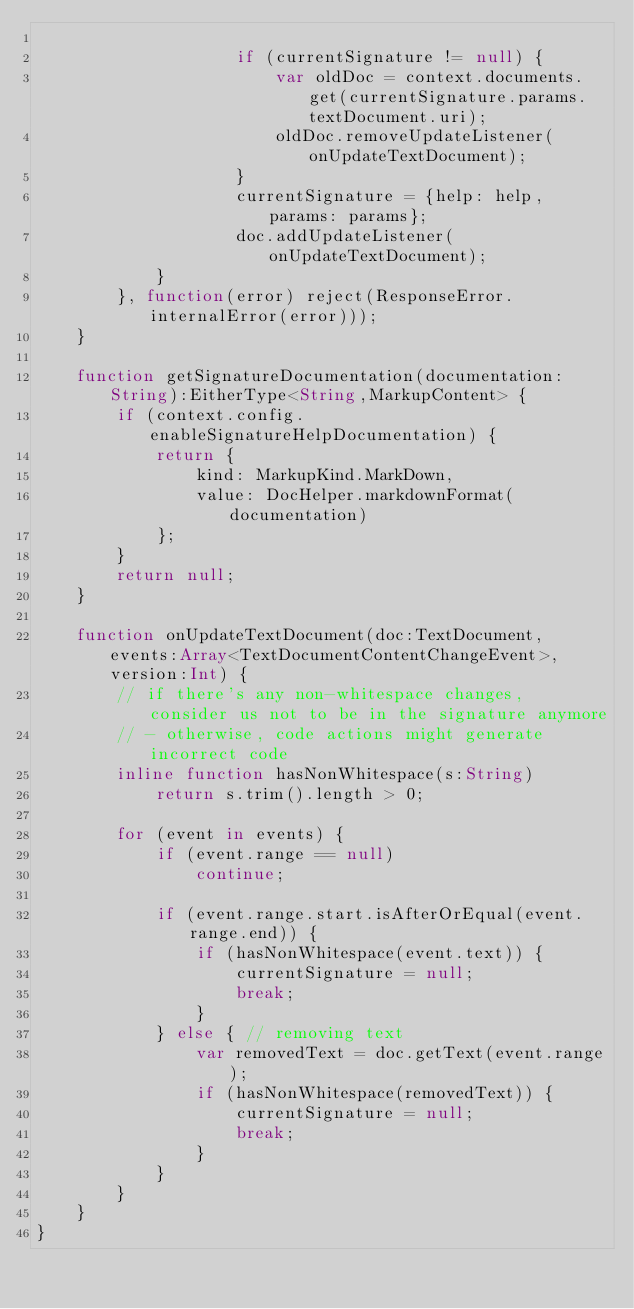Convert code to text. <code><loc_0><loc_0><loc_500><loc_500><_Haxe_>
                    if (currentSignature != null) {
                        var oldDoc = context.documents.get(currentSignature.params.textDocument.uri);
                        oldDoc.removeUpdateListener(onUpdateTextDocument);
                    }
                    currentSignature = {help: help, params: params};
                    doc.addUpdateListener(onUpdateTextDocument);
            }
        }, function(error) reject(ResponseError.internalError(error)));
    }

    function getSignatureDocumentation(documentation:String):EitherType<String,MarkupContent> {
        if (context.config.enableSignatureHelpDocumentation) {
            return {
                kind: MarkupKind.MarkDown,
                value: DocHelper.markdownFormat(documentation)
            };
        }
        return null;
    }

    function onUpdateTextDocument(doc:TextDocument, events:Array<TextDocumentContentChangeEvent>, version:Int) {
        // if there's any non-whitespace changes, consider us not to be in the signature anymore
        // - otherwise, code actions might generate incorrect code
        inline function hasNonWhitespace(s:String)
            return s.trim().length > 0;

        for (event in events) {
            if (event.range == null)
                continue;

            if (event.range.start.isAfterOrEqual(event.range.end)) {
                if (hasNonWhitespace(event.text)) {
                    currentSignature = null;
                    break;
                }
            } else { // removing text
                var removedText = doc.getText(event.range);
                if (hasNonWhitespace(removedText)) {
                    currentSignature = null;
                    break;
                }
            }
        }
    }
}
</code> 